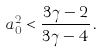Convert formula to latex. <formula><loc_0><loc_0><loc_500><loc_500>a _ { 0 } ^ { 2 } < \frac { 3 \gamma - 2 } { 3 \gamma - 4 } \, .</formula> 